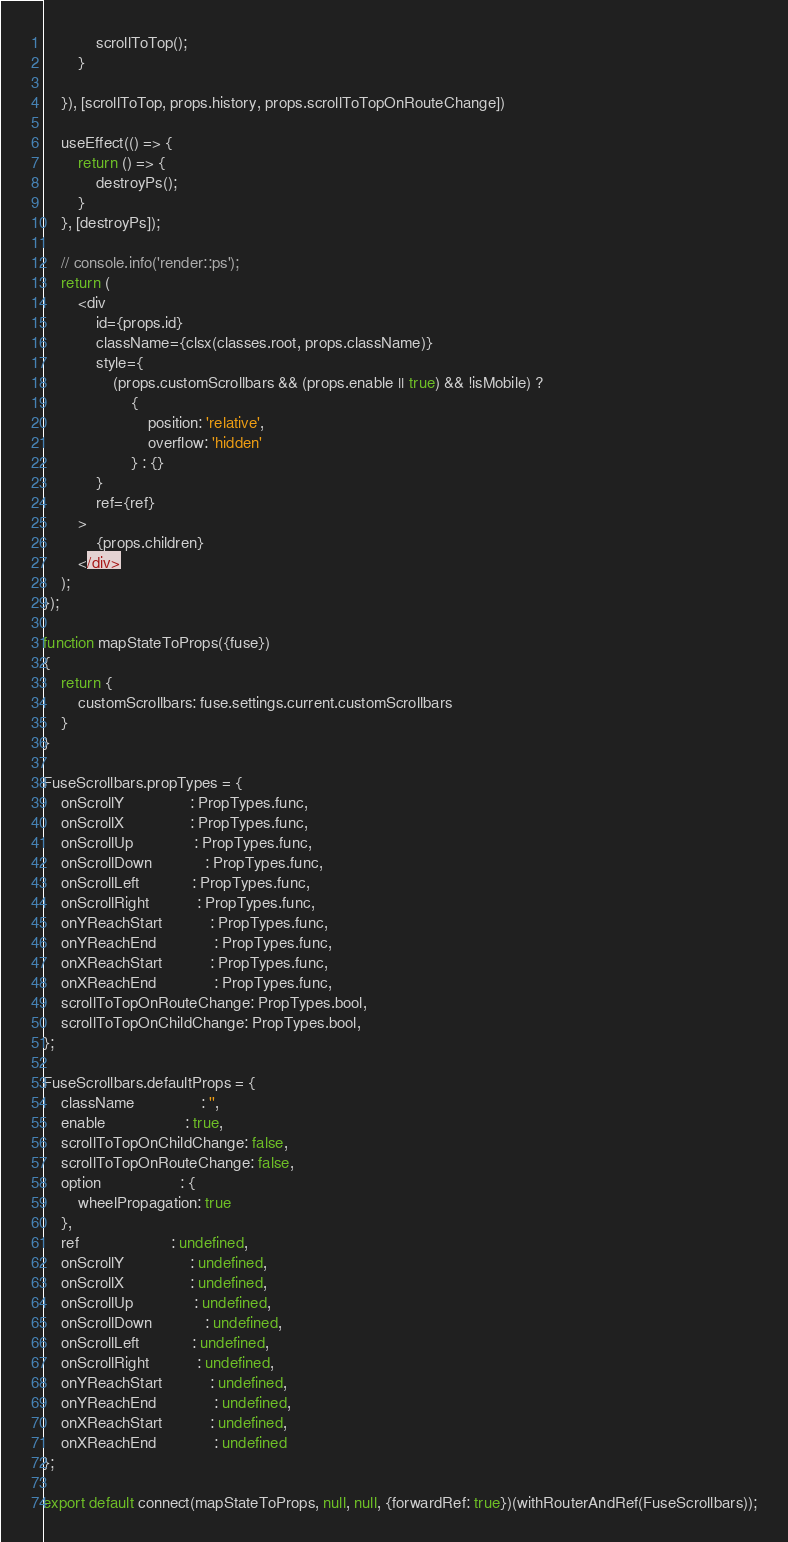Convert code to text. <code><loc_0><loc_0><loc_500><loc_500><_JavaScript_>            scrollToTop();
        }

    }), [scrollToTop, props.history, props.scrollToTopOnRouteChange])

    useEffect(() => {
        return () => {
            destroyPs();
        }
    }, [destroyPs]);

    // console.info('render::ps');
    return (
        <div
            id={props.id}
            className={clsx(classes.root, props.className)}
            style={
                (props.customScrollbars && (props.enable || true) && !isMobile) ?
                    {
                        position: 'relative',
                        overflow: 'hidden'
                    } : {}
            }
            ref={ref}
        >
            {props.children}
        </div>
    );
});

function mapStateToProps({fuse})
{
    return {
        customScrollbars: fuse.settings.current.customScrollbars
    }
}

FuseScrollbars.propTypes = {
    onScrollY               : PropTypes.func,
    onScrollX               : PropTypes.func,
    onScrollUp              : PropTypes.func,
    onScrollDown            : PropTypes.func,
    onScrollLeft            : PropTypes.func,
    onScrollRight           : PropTypes.func,
    onYReachStart           : PropTypes.func,
    onYReachEnd             : PropTypes.func,
    onXReachStart           : PropTypes.func,
    onXReachEnd             : PropTypes.func,
    scrollToTopOnRouteChange: PropTypes.bool,
    scrollToTopOnChildChange: PropTypes.bool,
};

FuseScrollbars.defaultProps = {
    className               : '',
    enable                  : true,
    scrollToTopOnChildChange: false,
    scrollToTopOnRouteChange: false,
    option                  : {
        wheelPropagation: true
    },
    ref                     : undefined,
    onScrollY               : undefined,
    onScrollX               : undefined,
    onScrollUp              : undefined,
    onScrollDown            : undefined,
    onScrollLeft            : undefined,
    onScrollRight           : undefined,
    onYReachStart           : undefined,
    onYReachEnd             : undefined,
    onXReachStart           : undefined,
    onXReachEnd             : undefined
};

export default connect(mapStateToProps, null, null, {forwardRef: true})(withRouterAndRef(FuseScrollbars));
</code> 